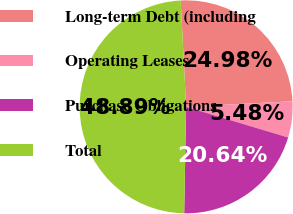<chart> <loc_0><loc_0><loc_500><loc_500><pie_chart><fcel>Long-term Debt (including<fcel>Operating Leases<fcel>Purchase Obligations<fcel>Total<nl><fcel>24.98%<fcel>5.48%<fcel>20.64%<fcel>48.89%<nl></chart> 